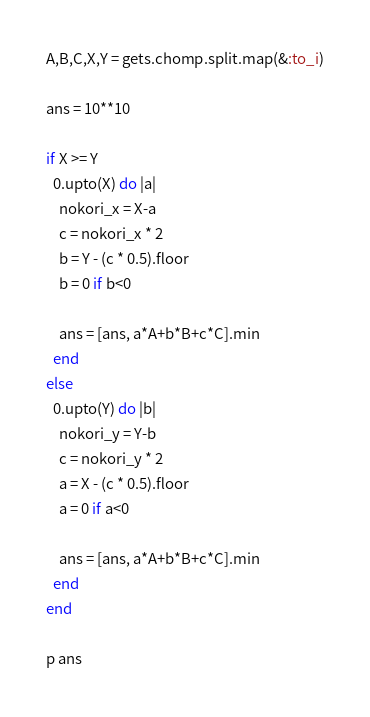Convert code to text. <code><loc_0><loc_0><loc_500><loc_500><_Ruby_>A,B,C,X,Y = gets.chomp.split.map(&:to_i)

ans = 10**10

if X >= Y
  0.upto(X) do |a|
    nokori_x = X-a
    c = nokori_x * 2
    b = Y - (c * 0.5).floor
    b = 0 if b<0

    ans = [ans, a*A+b*B+c*C].min
  end
else
  0.upto(Y) do |b|
    nokori_y = Y-b
    c = nokori_y * 2
    a = X - (c * 0.5).floor
    a = 0 if a<0

    ans = [ans, a*A+b*B+c*C].min
  end
end

p ans
</code> 